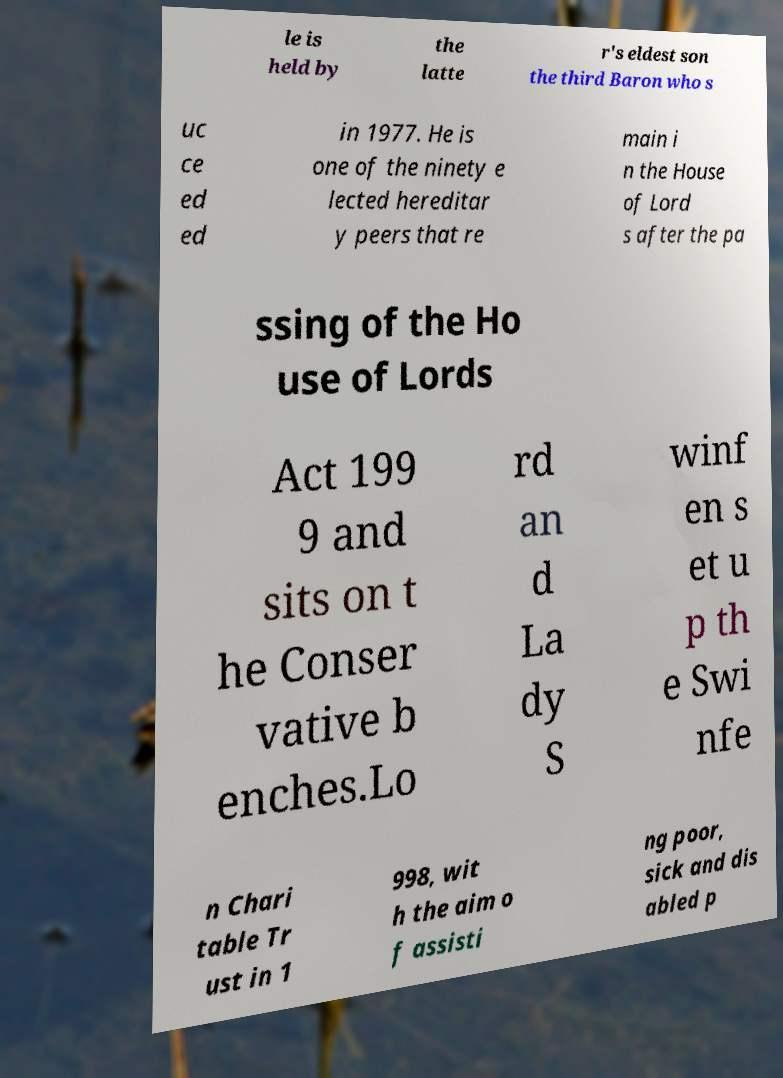Could you assist in decoding the text presented in this image and type it out clearly? le is held by the latte r's eldest son the third Baron who s uc ce ed ed in 1977. He is one of the ninety e lected hereditar y peers that re main i n the House of Lord s after the pa ssing of the Ho use of Lords Act 199 9 and sits on t he Conser vative b enches.Lo rd an d La dy S winf en s et u p th e Swi nfe n Chari table Tr ust in 1 998, wit h the aim o f assisti ng poor, sick and dis abled p 